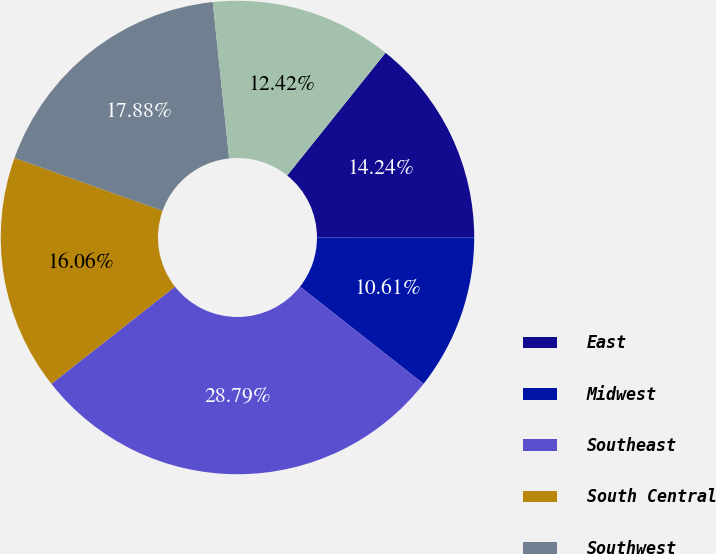<chart> <loc_0><loc_0><loc_500><loc_500><pie_chart><fcel>East<fcel>Midwest<fcel>Southeast<fcel>South Central<fcel>Southwest<fcel>West<nl><fcel>14.24%<fcel>10.61%<fcel>28.79%<fcel>16.06%<fcel>17.88%<fcel>12.42%<nl></chart> 